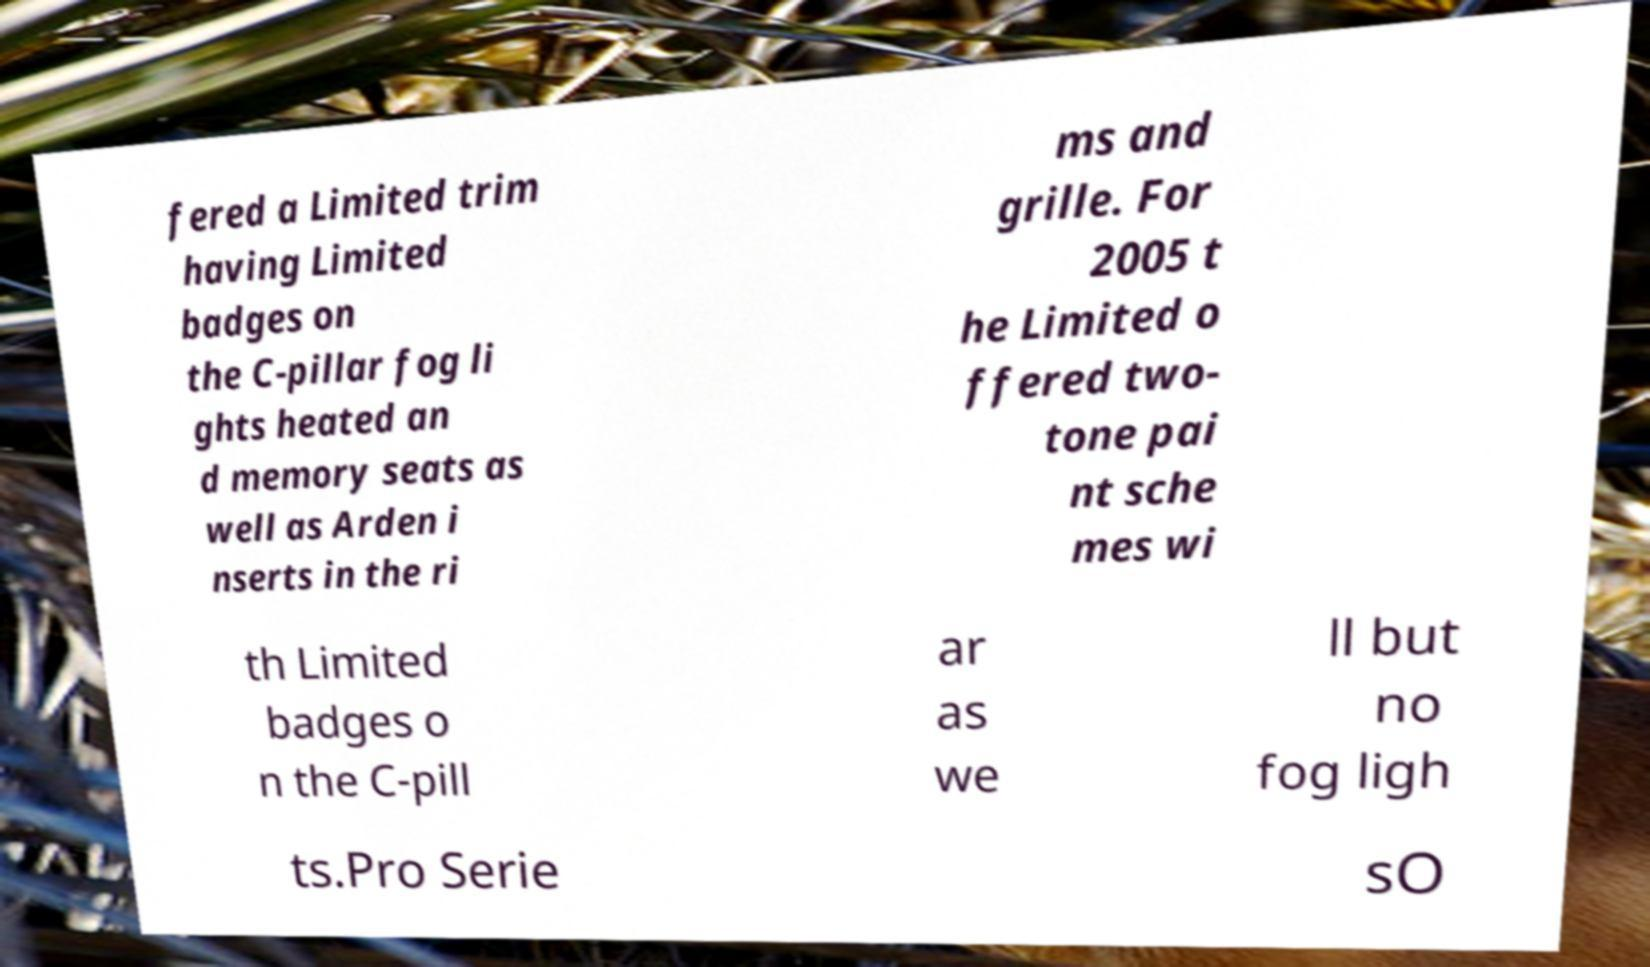I need the written content from this picture converted into text. Can you do that? fered a Limited trim having Limited badges on the C-pillar fog li ghts heated an d memory seats as well as Arden i nserts in the ri ms and grille. For 2005 t he Limited o ffered two- tone pai nt sche mes wi th Limited badges o n the C-pill ar as we ll but no fog ligh ts.Pro Serie sO 